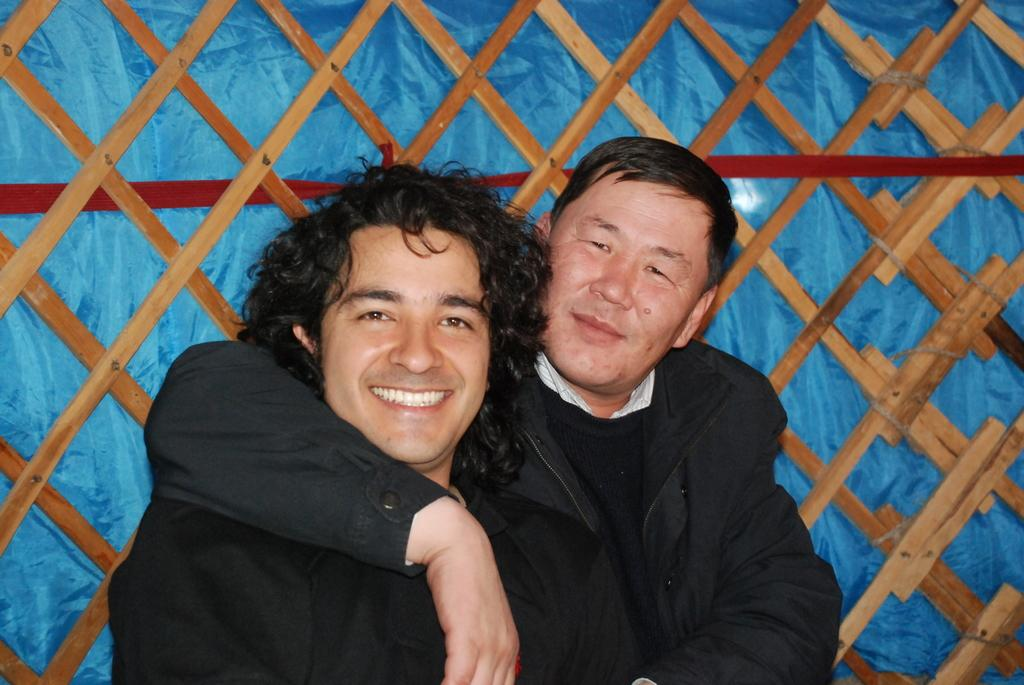How many people are present in the image? There are a few people in the image. What can be seen in the background of the image? There is blue colored cloth with a ribbon in the background, and there are wooden objects as well. What type of coat is the person wearing in the image? There is no coat visible in the image; the people are not wearing any coats. What is the person's interest in the image? The image does not provide information about the person's interests. 